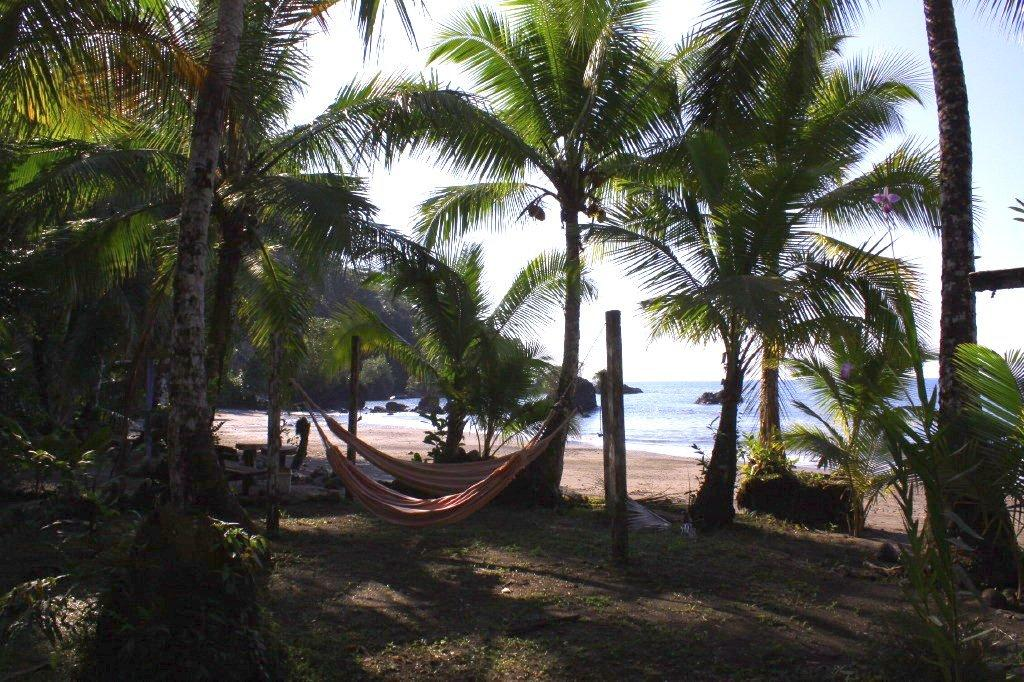What can be seen in the sky in the image? The sky is visible in the image. What is the water in the image? There is water in the image. What type of vegetation is present in the image? Trees and grass are visible in the image. What are people using to relax in the image? Hammocks are present in the image. What other objects can be seen in the image? There are a few other objects in the image. How many ducks are swimming in the water in the image? There are no ducks present in the image; it only features water, trees, grass, hammocks, and a few other objects. 